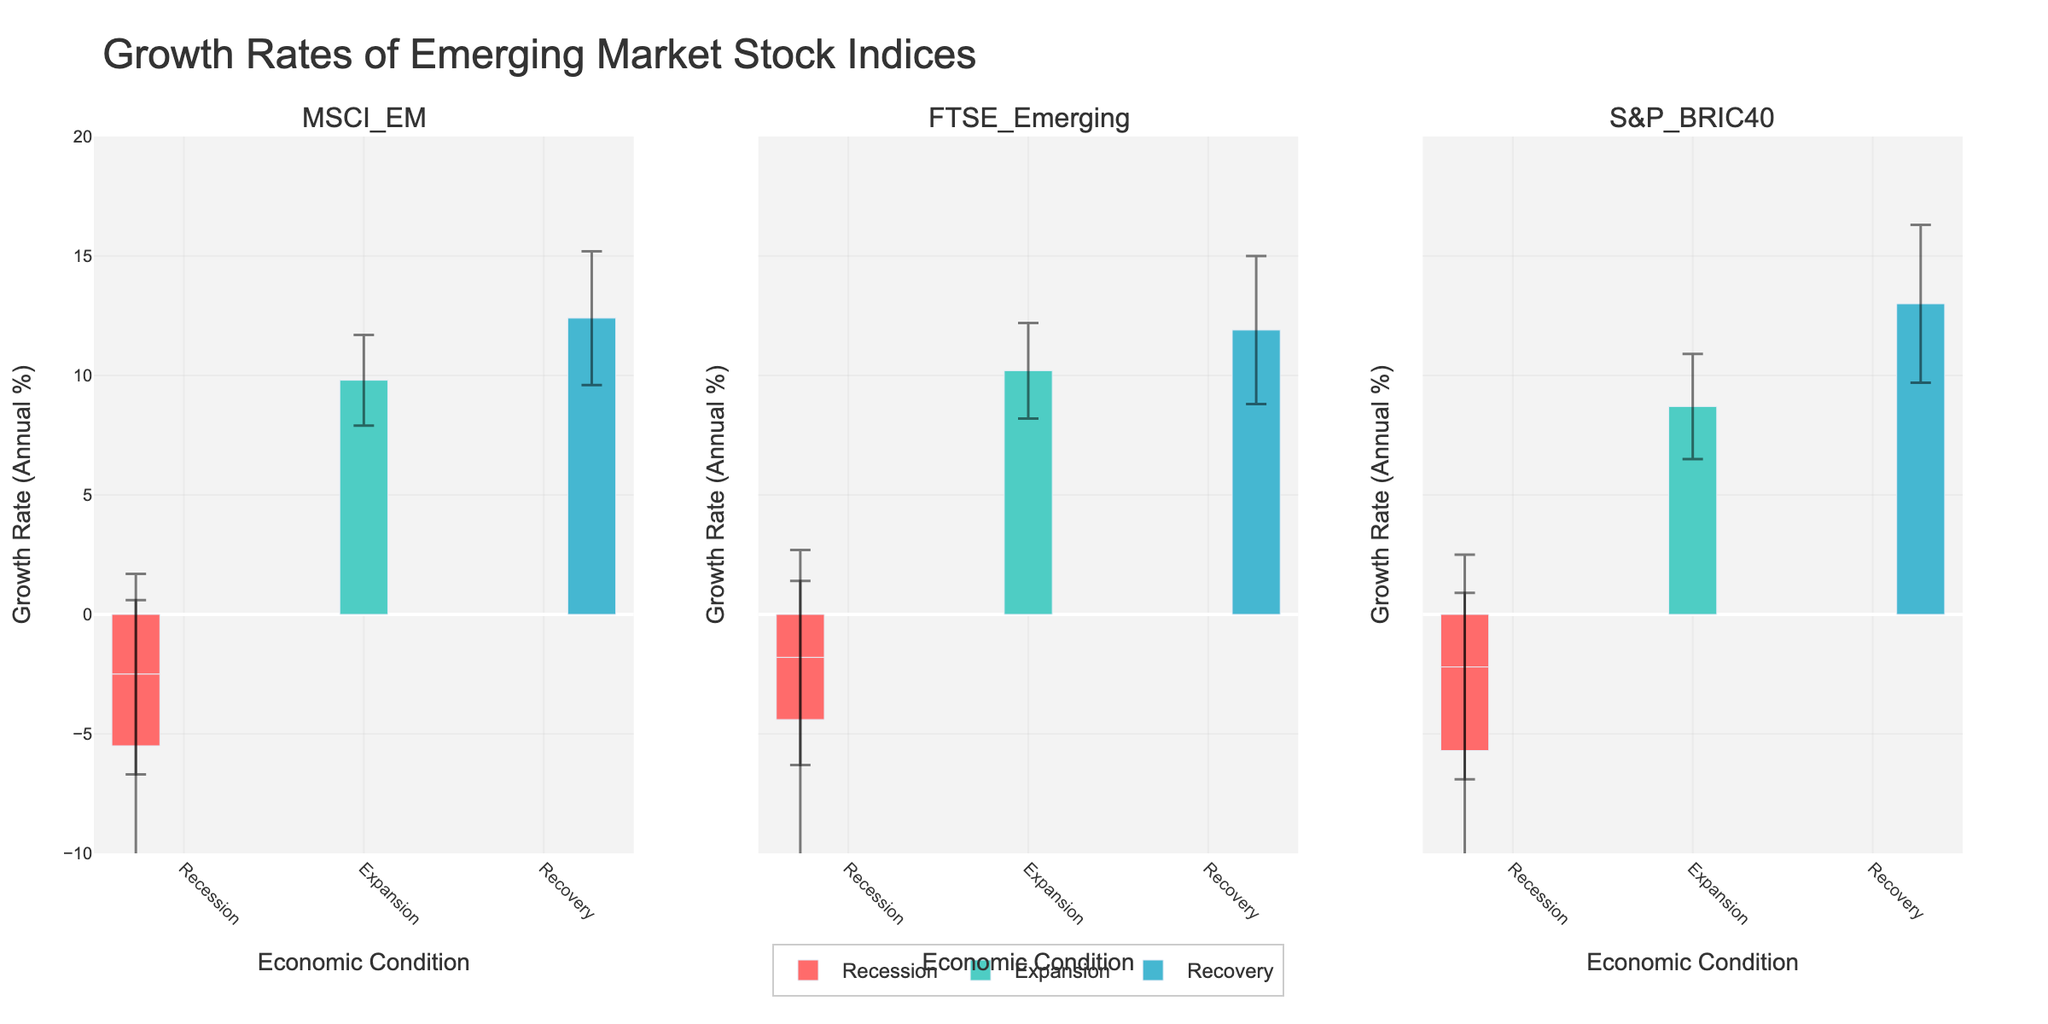What is the title of the figure? The title of the figure can be found centered at the top.
Answer: Growth Rates of Emerging Market Stock Indices What is the growth rate of the MSCI_EM index during the Expansion period? Look at the MSCI_EM subplot and check the bar corresponding to the Expansion period. Read the height value.
Answer: 9.8% What is the range of the y-axis? Look at the y-axis on any subplot and observe the maximum and minimum values indicated.
Answer: -10 to 20 Which economic condition has the highest growth rate for the S&P_BRIC40 index? Examine the S&P_BRIC40 subplot and compare the heights of the bars for different economic conditions. The highest bar represents the highest growth rate.
Answer: Recovery What is the standard deviation of the FTSE_Emerging index during the 2015-2016 recession period? In the FTSE_Emerging subplot, find the bar for the 2015-2016 period and check the vertical line (error bar) associated with it. Read the value of the standard deviation.
Answer: 4.5% During which economic condition did the MSCI_EM index have a negative growth rate? Look at the MSCI_EM subplot and identify the bars that are below the zero line. Check the corresponding economic conditions.
Answer: Recession Which index experienced the highest growth rate during the Recovery period? Compare the heights of the bars corresponding to the Recovery period in all subplots. The tallest bar indicates the highest growth rate.
Answer: S&P_BRIC40 What is the difference in growth rates between Expansion and Recession periods for the FTSE_Emerging index? Find the growth rates of the FTSE_Emerging index during Expansion and Recession. Subtract the Recession growth rate from the Expansion growth rate. 10.2 - (-1.8) = 10.2 + 1.8
Answer: 12.0% Which index has the smallest standard deviation during the Recovery period? Look at each subplot's error bars during the Recovery period and identify the smallest one.
Answer: MSCI_EM What can you infer about the stability of the S&P_BRIC40 index during the periods of Recession vs. Expansion? Compare the standard deviations (error bars' lengths) of S&P_BRIC40 during Recession and Expansion. A shorter error bar indicates more stability (less variability).
Answer: S&P_BRIC40 is more stable during Expansion than Recession 